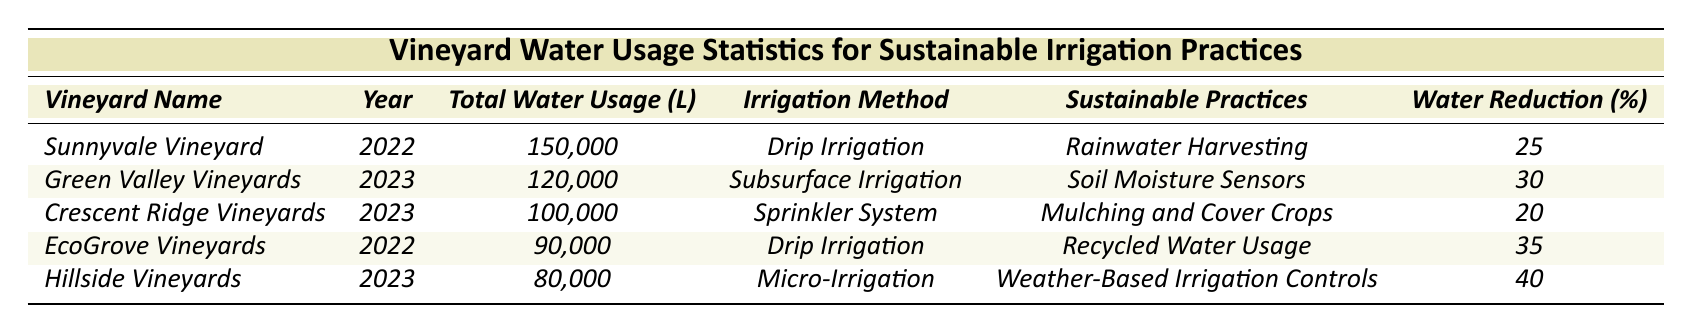What is the total water usage for Sunnyvale Vineyard in 2022? The table shows that Sunnyvale Vineyard's total water usage in 2022 is listed as 150,000 liters.
Answer: 150,000 liters Which vineyard implemented rainwater harvesting? The table indicates that Sunnyvale Vineyard implemented rainwater harvesting, as seen in the sustainable practices column for the year 2022.
Answer: Sunnyvale Vineyard In which year did Hillside Vineyards use 80,000 liters of water? According to the table, Hillside Vineyards used 80,000 liters of water in the year 2023.
Answer: 2023 What percentage of water reduction is reported for EcoGrove Vineyards? The table shows that EcoGrove Vineyards achieved a water usage reduction percentage of 35%.
Answer: 35% How many liters of water did Green Valley Vineyards use less than Sunnyvale Vineyard in 2023? Green Valley Vineyards used 120,000 liters in 2023 while Sunnyvale Vineyard used 150,000 liters in 2022. The difference in usage is 150,000 - 120,000 = 30,000 liters.
Answer: 30,000 liters Which vineyard had the highest water usage reduction percentage and what was that percentage? Hillside Vineyards had the highest water usage reduction percentage at 40%, as indicated in the table for the year 2023.
Answer: 40% What is the average total water usage for the vineyards listed in 2023? The total water usage for the vineyards in 2023 includes 120,000 (Green Valley) + 100,000 (Crescent Ridge) + 80,000 (Hillside) = 300,000 liters. There are 3 vineyards listed in that year, so the average is 300,000 / 3 = 100,000 liters.
Answer: 100,000 liters Did any vineyard use less than 90,000 liters of water in 2023? The table shows that Hillside Vineyards used 80,000 liters in 2023, which is less than 90,000 liters. Therefore, yes, there is a vineyard that used less.
Answer: Yes Which sustainable practice was used by Crescent Ridge Vineyards in 2023? According to the table, Crescent Ridge Vineyards implemented mulching and cover crops as their sustainable practice in 2023.
Answer: Mulching and cover crops What is the total water usage in liters for all vineyards listed in 2022? The total water usage for 2022 is 150,000 (Sunnyvale) + 90,000 (EcoGrove) = 240,000 liters. Thus, the total water usage in 2022 is calculated to be 240,000 liters.
Answer: 240,000 liters 